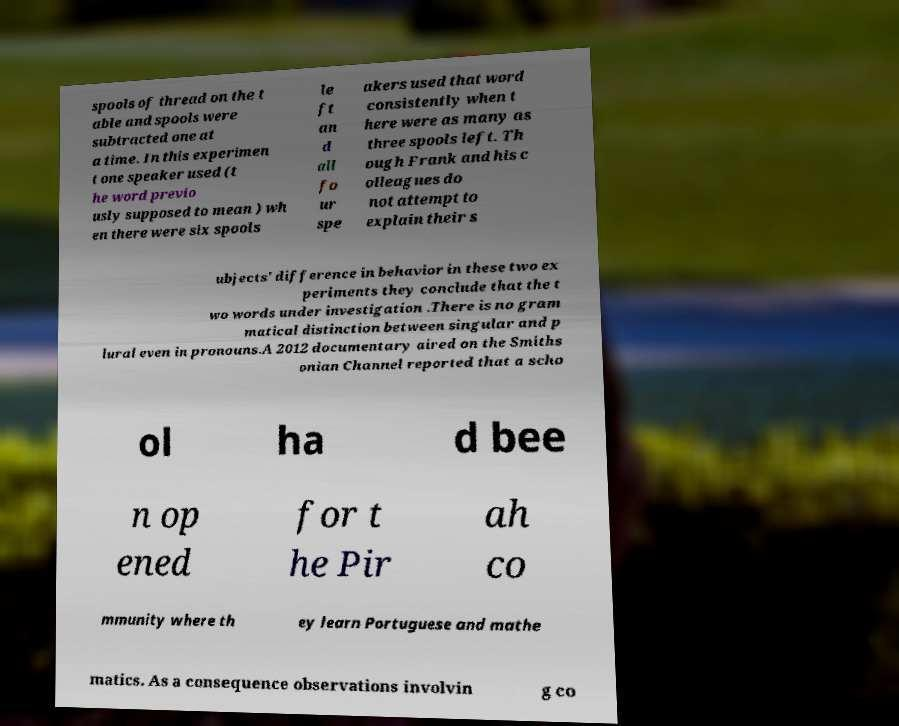Can you accurately transcribe the text from the provided image for me? spools of thread on the t able and spools were subtracted one at a time. In this experimen t one speaker used (t he word previo usly supposed to mean ) wh en there were six spools le ft an d all fo ur spe akers used that word consistently when t here were as many as three spools left. Th ough Frank and his c olleagues do not attempt to explain their s ubjects' difference in behavior in these two ex periments they conclude that the t wo words under investigation .There is no gram matical distinction between singular and p lural even in pronouns.A 2012 documentary aired on the Smiths onian Channel reported that a scho ol ha d bee n op ened for t he Pir ah co mmunity where th ey learn Portuguese and mathe matics. As a consequence observations involvin g co 